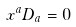Convert formula to latex. <formula><loc_0><loc_0><loc_500><loc_500>x ^ { a } D _ { a } = 0</formula> 